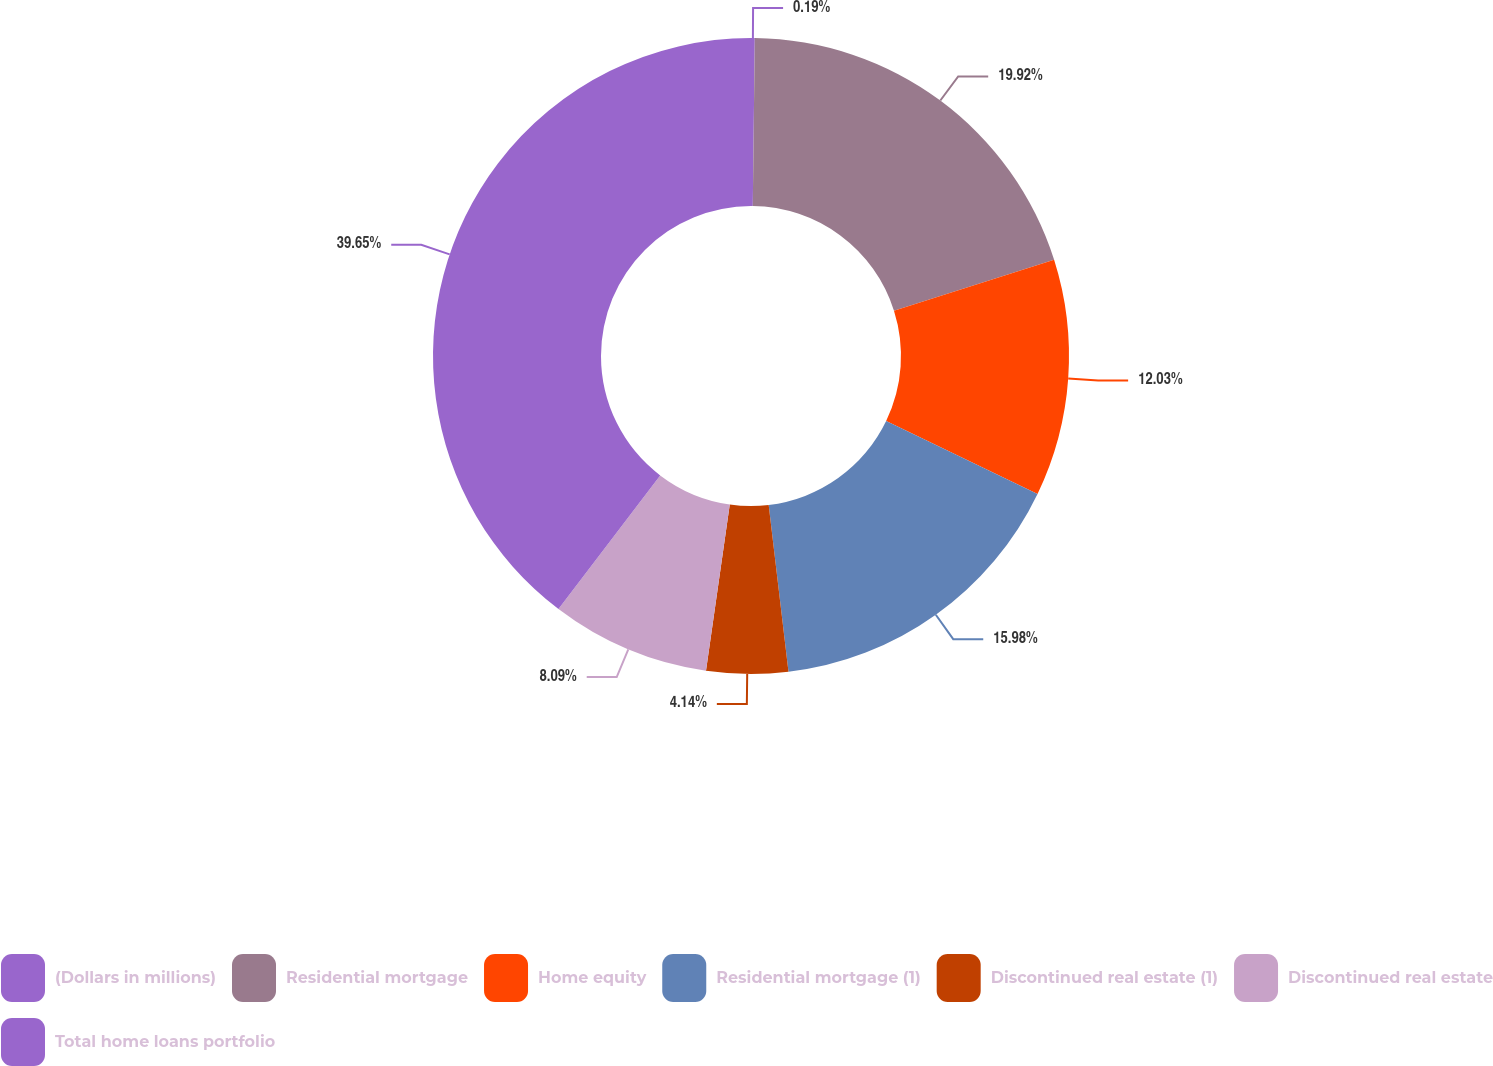Convert chart. <chart><loc_0><loc_0><loc_500><loc_500><pie_chart><fcel>(Dollars in millions)<fcel>Residential mortgage<fcel>Home equity<fcel>Residential mortgage (1)<fcel>Discontinued real estate (1)<fcel>Discontinued real estate<fcel>Total home loans portfolio<nl><fcel>0.19%<fcel>19.92%<fcel>12.03%<fcel>15.98%<fcel>4.14%<fcel>8.09%<fcel>39.65%<nl></chart> 